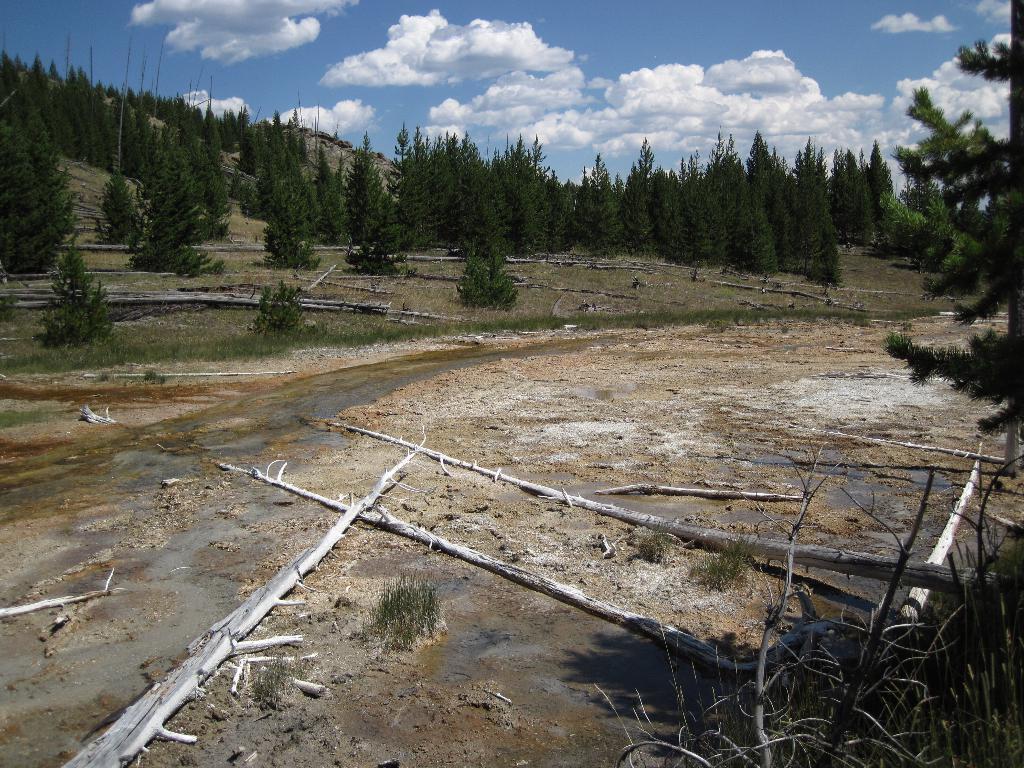How would you summarize this image in a sentence or two? In this picture we can see there are branches and water on the path. Behind the branches there are trees and a sky. 